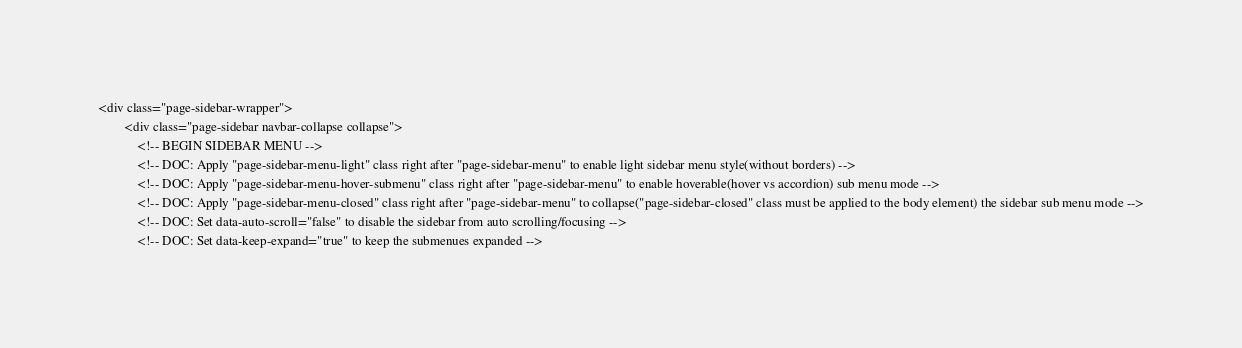Convert code to text. <code><loc_0><loc_0><loc_500><loc_500><_PHP_><div class="page-sidebar-wrapper">
		<div class="page-sidebar navbar-collapse collapse">
			<!-- BEGIN SIDEBAR MENU -->
			<!-- DOC: Apply "page-sidebar-menu-light" class right after "page-sidebar-menu" to enable light sidebar menu style(without borders) -->
			<!-- DOC: Apply "page-sidebar-menu-hover-submenu" class right after "page-sidebar-menu" to enable hoverable(hover vs accordion) sub menu mode -->
			<!-- DOC: Apply "page-sidebar-menu-closed" class right after "page-sidebar-menu" to collapse("page-sidebar-closed" class must be applied to the body element) the sidebar sub menu mode -->
			<!-- DOC: Set data-auto-scroll="false" to disable the sidebar from auto scrolling/focusing -->
			<!-- DOC: Set data-keep-expand="true" to keep the submenues expanded --></code> 